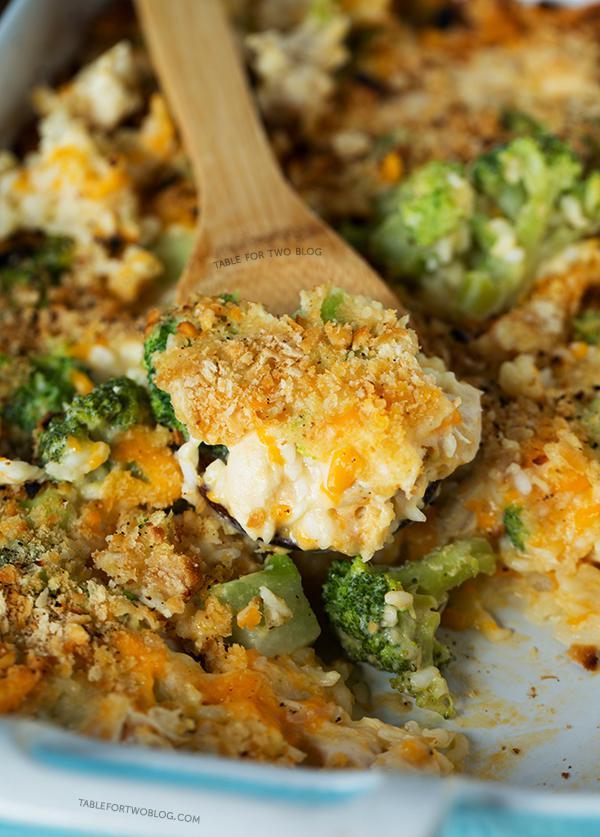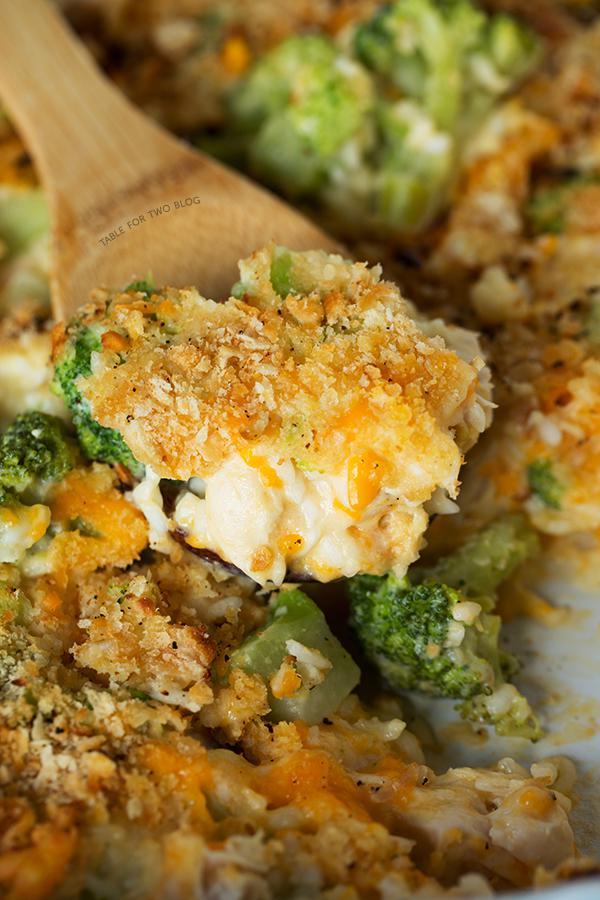The first image is the image on the left, the second image is the image on the right. Examine the images to the left and right. Is the description "Right image shows a casserole served in a white squarish dish, with a silver serving utensil." accurate? Answer yes or no. No. 